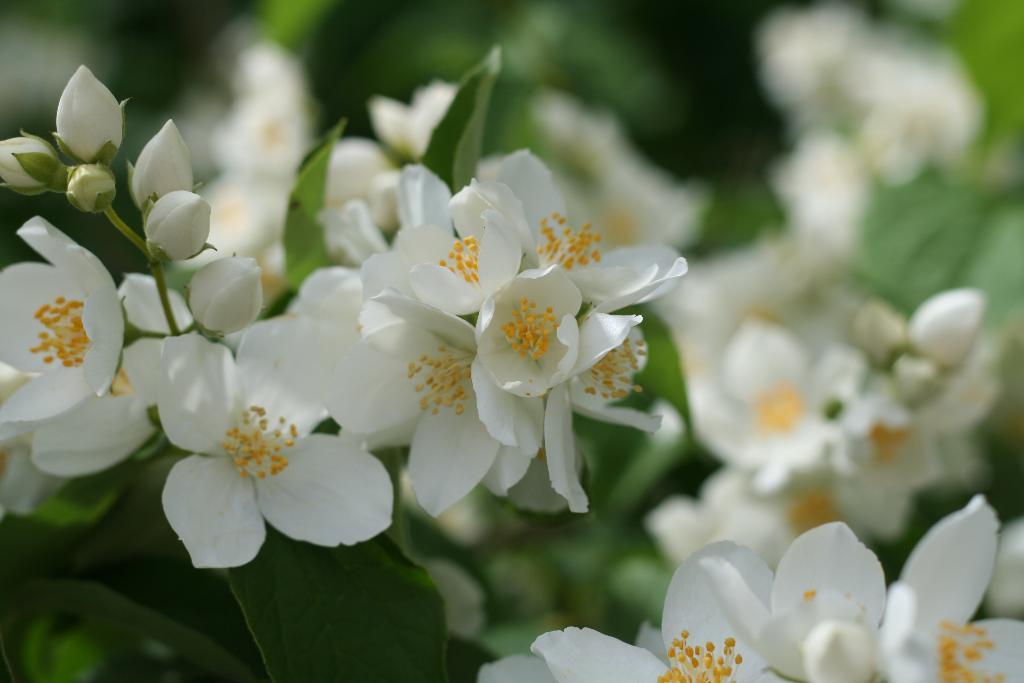Please provide a concise description of this image. In this image there are so many small white flowers in the middle. There are buds in between the flowers. In the background there are green leaves. 